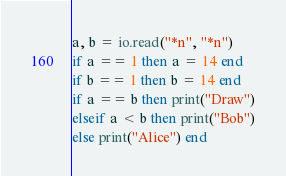<code> <loc_0><loc_0><loc_500><loc_500><_Lua_>a, b = io.read("*n", "*n")
if a == 1 then a = 14 end
if b == 1 then b = 14 end
if a == b then print("Draw")
elseif a < b then print("Bob")
else print("Alice") end
</code> 